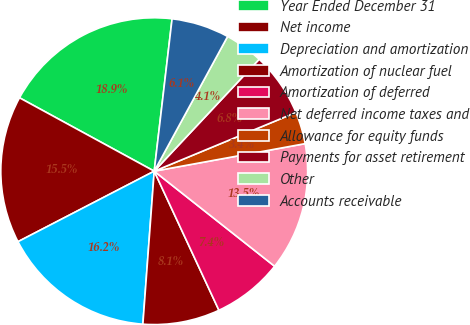<chart> <loc_0><loc_0><loc_500><loc_500><pie_chart><fcel>Year Ended December 31<fcel>Net income<fcel>Depreciation and amortization<fcel>Amortization of nuclear fuel<fcel>Amortization of deferred<fcel>Net deferred income taxes and<fcel>Allowance for equity funds<fcel>Payments for asset retirement<fcel>Other<fcel>Accounts receivable<nl><fcel>18.92%<fcel>15.54%<fcel>16.22%<fcel>8.11%<fcel>7.43%<fcel>13.51%<fcel>3.38%<fcel>6.76%<fcel>4.05%<fcel>6.08%<nl></chart> 